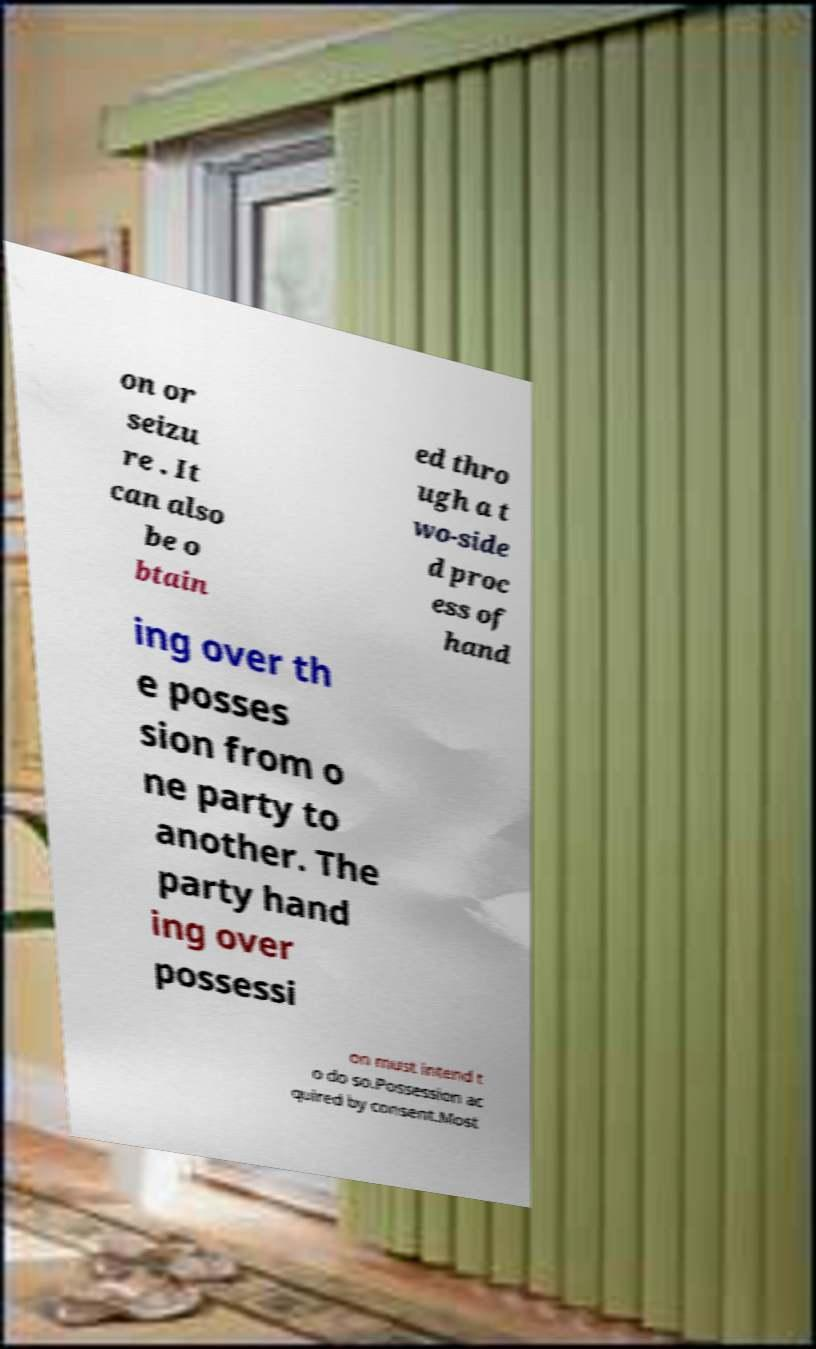I need the written content from this picture converted into text. Can you do that? on or seizu re . It can also be o btain ed thro ugh a t wo-side d proc ess of hand ing over th e posses sion from o ne party to another. The party hand ing over possessi on must intend t o do so.Possession ac quired by consent.Most 